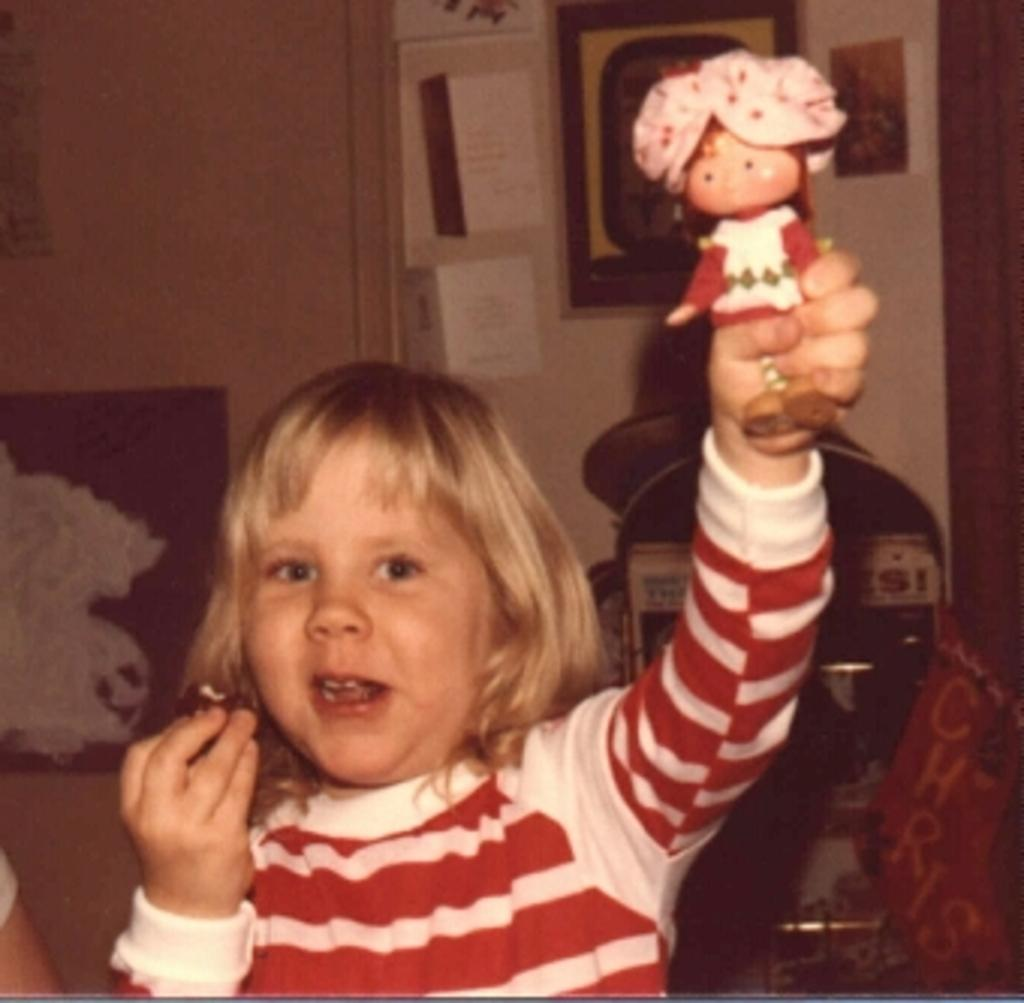Who is the main subject in the image? There is a girl in the image. What is the girl wearing? The girl is wearing a red dress. What is the girl holding in her hands? The girl is holding a toy in her hands. What can be seen in the background of the image? There is a wall in the background of the image. How much salt is on the girl's dress in the image? There is no salt visible on the girl's dress in the image. What type of ball is the girl playing with in the image? There is no ball present in the image; the girl is holding a toy. 